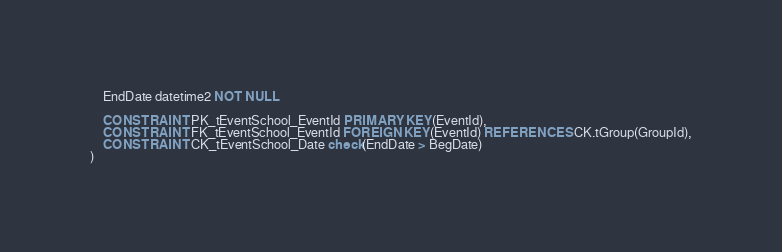<code> <loc_0><loc_0><loc_500><loc_500><_SQL_>	EndDate datetime2 NOT NULL
  
    CONSTRAINT PK_tEventSchool_EventId PRIMARY KEY(EventId),
    CONSTRAINT FK_tEventSchool_EventId FOREIGN KEY(EventId) REFERENCES CK.tGroup(GroupId),
	CONSTRAINT CK_tEventSchool_Date check(EndDate > BegDate)
)
</code> 